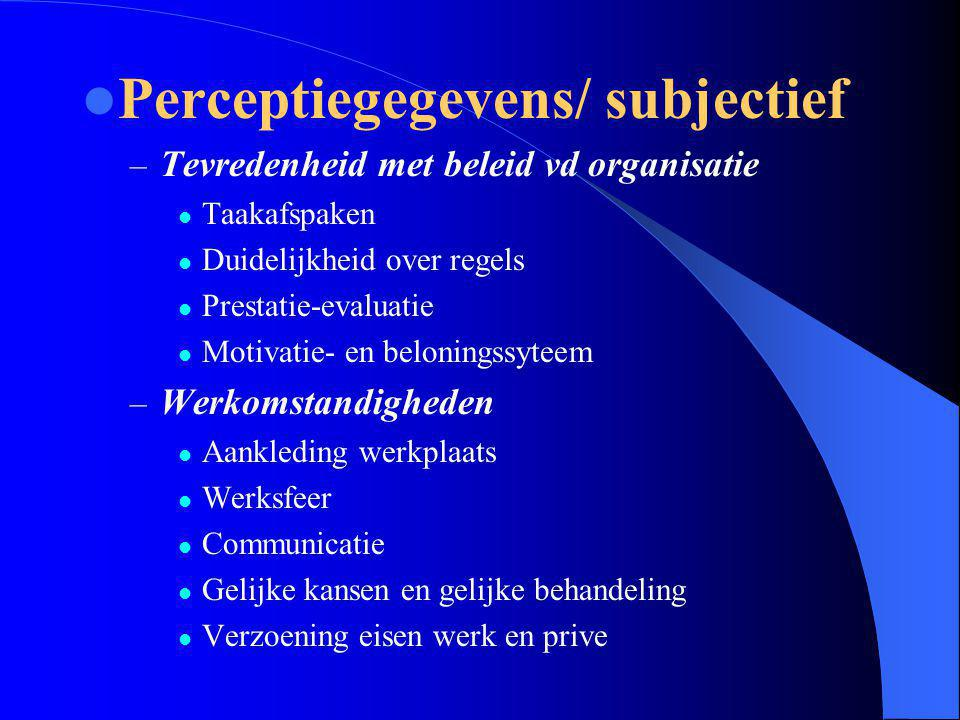What does the term "Taakafspraken" refer to in the context of this presentation? In the context of the slide, "Taakafspraken" likely refers to task agreements or commitments made between employees and management regarding their responsibilities and duties. This ensures clear understanding and agreement on what is expected of each team member in terms of their deliverables and contributions to the organization. 